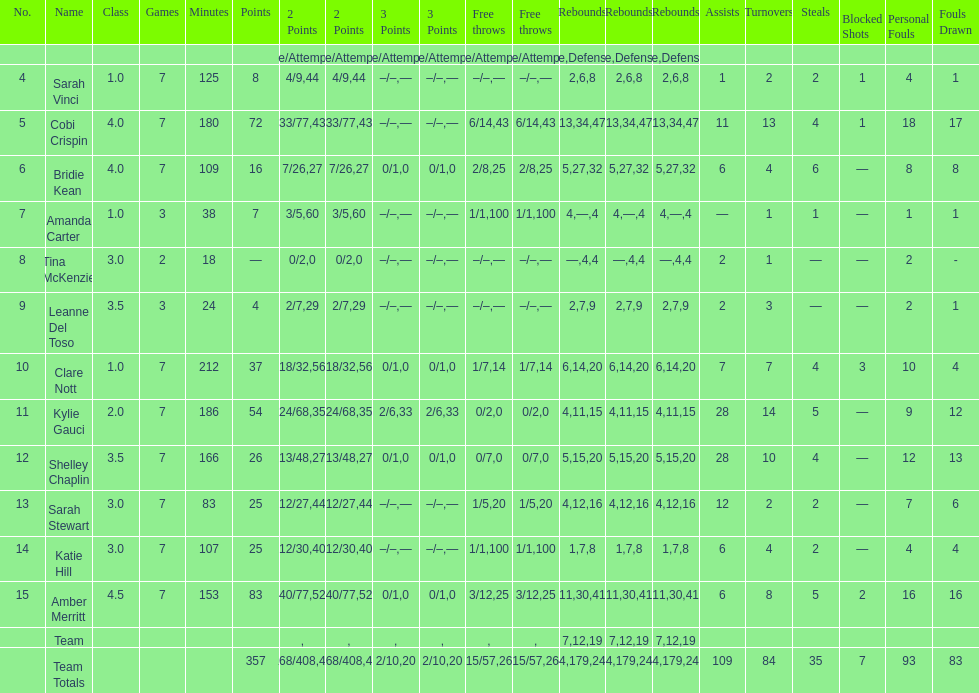What is the difference between the highest scoring player's points and the lowest scoring player's points? 83. Write the full table. {'header': ['No.', 'Name', 'Class', 'Games', 'Minutes', 'Points', '2 Points', '2 Points', '3 Points', '3 Points', 'Free throws', 'Free throws', 'Rebounds', 'Rebounds', 'Rebounds', 'Assists', 'Turnovers', 'Steals', 'Blocked Shots', 'Personal Fouls', 'Fouls Drawn'], 'rows': [['', '', '', '', '', '', 'Made/Attempts', '%', 'Made/Attempts', '%', 'Made/Attempts', '%', 'Offensive', 'Defensive', 'Total', '', '', '', '', '', ''], ['4', 'Sarah Vinci', '1.0', '7', '125', '8', '4/9', '44', '–/–', '—', '–/–', '—', '2', '6', '8', '1', '2', '2', '1', '4', '1'], ['5', 'Cobi Crispin', '4.0', '7', '180', '72', '33/77', '43', '–/–', '—', '6/14', '43', '13', '34', '47', '11', '13', '4', '1', '18', '17'], ['6', 'Bridie Kean', '4.0', '7', '109', '16', '7/26', '27', '0/1', '0', '2/8', '25', '5', '27', '32', '6', '4', '6', '—', '8', '8'], ['7', 'Amanda Carter', '1.0', '3', '38', '7', '3/5', '60', '–/–', '—', '1/1', '100', '4', '—', '4', '—', '1', '1', '—', '1', '1'], ['8', 'Tina McKenzie', '3.0', '2', '18', '—', '0/2', '0', '–/–', '—', '–/–', '—', '—', '4', '4', '2', '1', '—', '—', '2', '-'], ['9', 'Leanne Del Toso', '3.5', '3', '24', '4', '2/7', '29', '–/–', '—', '–/–', '—', '2', '7', '9', '2', '3', '—', '—', '2', '1'], ['10', 'Clare Nott', '1.0', '7', '212', '37', '18/32', '56', '0/1', '0', '1/7', '14', '6', '14', '20', '7', '7', '4', '3', '10', '4'], ['11', 'Kylie Gauci', '2.0', '7', '186', '54', '24/68', '35', '2/6', '33', '0/2', '0', '4', '11', '15', '28', '14', '5', '—', '9', '12'], ['12', 'Shelley Chaplin', '3.5', '7', '166', '26', '13/48', '27', '0/1', '0', '0/7', '0', '5', '15', '20', '28', '10', '4', '—', '12', '13'], ['13', 'Sarah Stewart', '3.0', '7', '83', '25', '12/27', '44', '–/–', '—', '1/5', '20', '4', '12', '16', '12', '2', '2', '—', '7', '6'], ['14', 'Katie Hill', '3.0', '7', '107', '25', '12/30', '40', '–/–', '—', '1/1', '100', '1', '7', '8', '6', '4', '2', '—', '4', '4'], ['15', 'Amber Merritt', '4.5', '7', '153', '83', '40/77', '52', '0/1', '0', '3/12', '25', '11', '30', '41', '6', '8', '5', '2', '16', '16'], ['', 'Team', '', '', '', '', '', '', '', '', '', '', '7', '12', '19', '', '', '', '', '', ''], ['', 'Team Totals', '', '', '', '357', '168/408', '41', '2/10', '20', '15/57', '26', '64', '179', '243', '109', '84', '35', '7', '93', '83']]} 